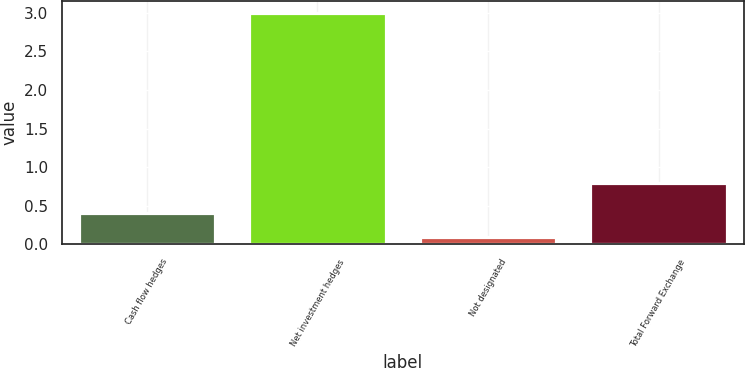Convert chart. <chart><loc_0><loc_0><loc_500><loc_500><bar_chart><fcel>Cash flow hedges<fcel>Net investment hedges<fcel>Not designated<fcel>Total Forward Exchange<nl><fcel>0.4<fcel>3<fcel>0.1<fcel>0.8<nl></chart> 